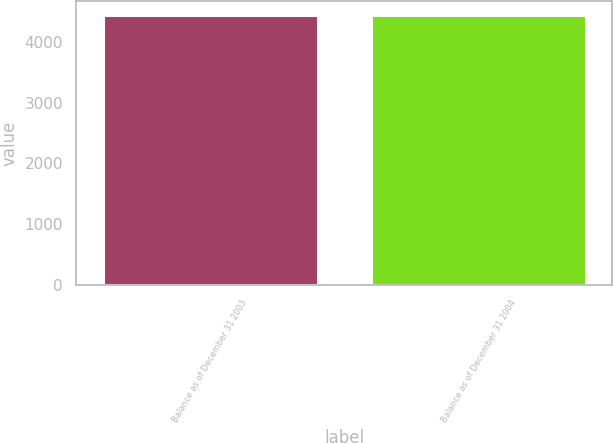Convert chart. <chart><loc_0><loc_0><loc_500><loc_500><bar_chart><fcel>Balance as of December 31 2003<fcel>Balance as of December 31 2004<nl><fcel>4448<fcel>4448.1<nl></chart> 